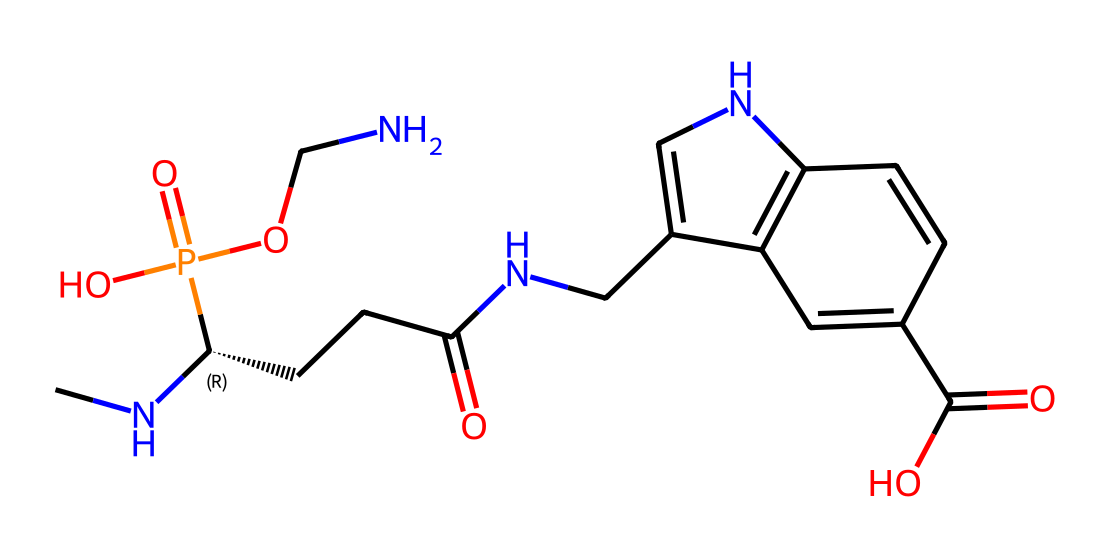What is the molecular formula of this compound? To determine the molecular formula, we need to count the different types of atoms present in the chemical structure as represented by the SMILES. In this case, the atoms include carbons (C), hydrogens (H), nitrogens (N), oxygens (O), and phosphorus (P). By analyzing the structure from the SMILES representation, we find that there are 14 carbons, 20 hydrogens, 4 nitrogens, 5 oxygens, and 1 phosphorus, resulting in the molecular formula C14H20N4O5P.
Answer: C14H20N4O5P How many rings are present in this chemical structure? To determine the number of rings, we examine the structure for any closed loops formed by the atoms. Upon careful inspection of the SMILES, we can identify a single cyclic structure with 2 nitrogen atoms and a connection between carbons. Therefore, there is one ring in this molecule.
Answer: 1 What class of drug does this compound belong to? This compound is categorized as a disease-modifying antirheumatic drug (DMARD), typically used in autoimmune conditions such as psoriasis. The presence of nitrogen and phosphorylation suggests its role in inhibiting cell proliferation and modulating immune response in such diseases.
Answer: DMARD What is the function of the nitrogen atoms in this structure? The nitrogen atoms play a critical role in the pharmacological action of methotrexate. They are involved in the drug's interaction with enzymes that are important for purine and pyrimidine synthesis, effectively inhibiting cellular division in rapidly proliferating cells, like those in psoriasis.
Answer: inhibit cell division Which functional groups are present in this chemical? To identify functional groups, we analyze the parts of the molecular structure. In this case, we can highlight the presence of amine groups (NH2), carboxylic acid groups (COOH), and a phosphate group (-OPO3H2). These groups are instrumental in the drug's reactivity and activity.
Answer: amine, carboxylic acid, phosphate What is the significance of the phosphorus atom in this drug? The phosphorus atom is significant as it is part of the phosphate group which is critical for the drug's mechanism of action. This group aids in the drug's ability to inhibit enzymes necessary for DNA synthesis, thus impacting cell function and supporting its therapeutic effects in psoriasis management.
Answer: inhibit enzymes 